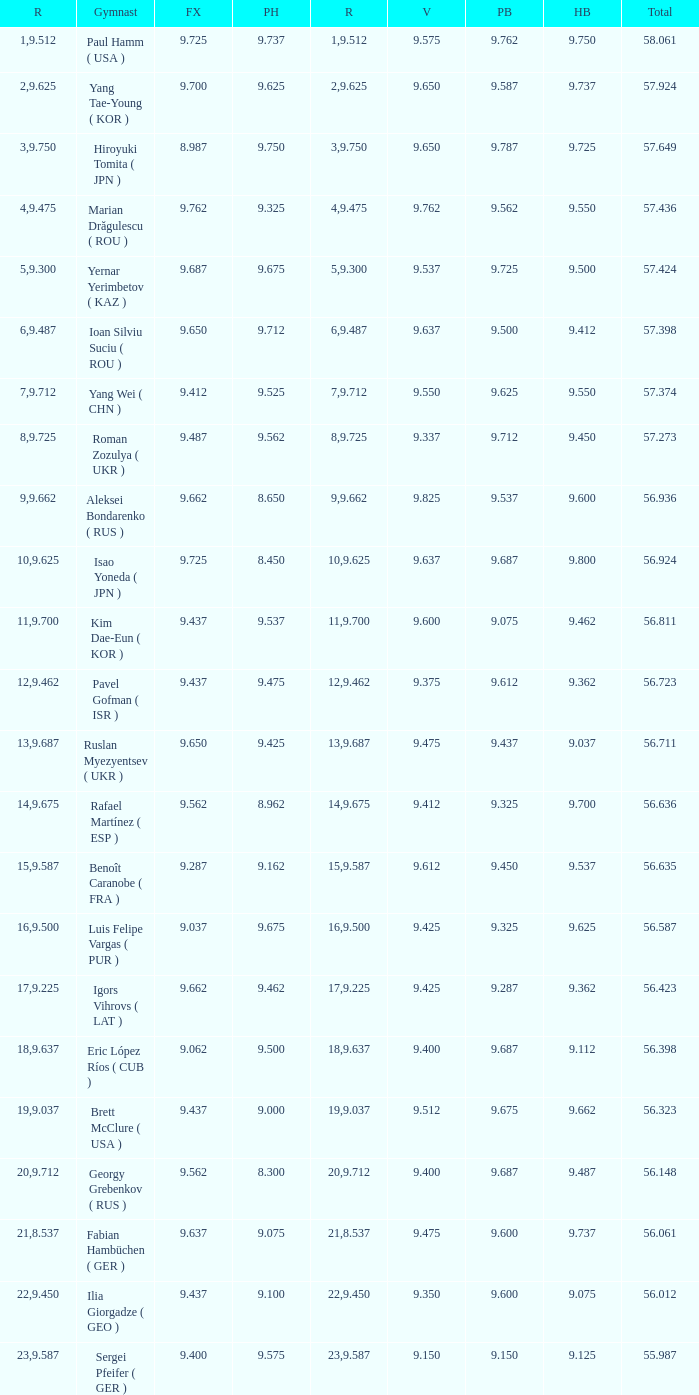What is the total score when the score for floor exercise was 9.287? 56.635. 